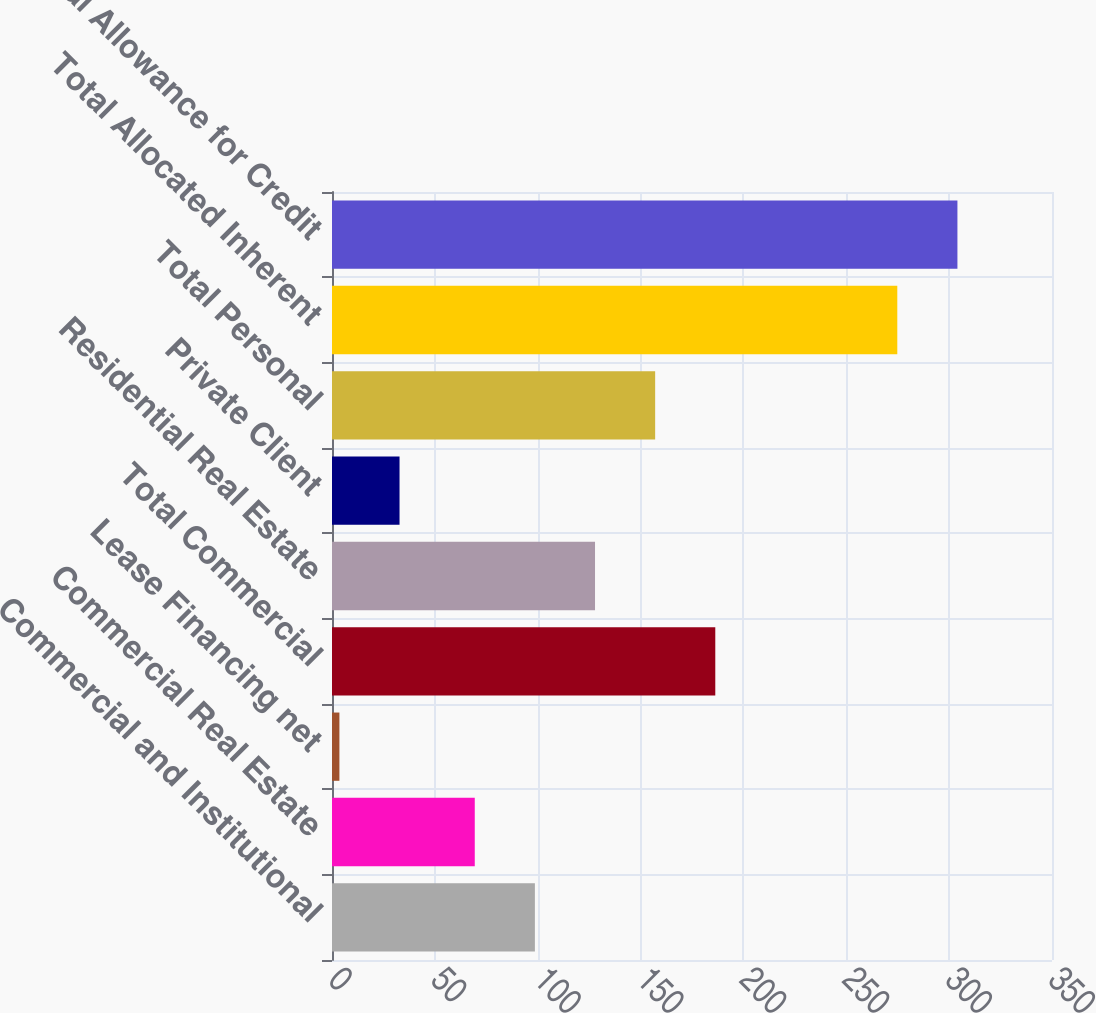Convert chart to OTSL. <chart><loc_0><loc_0><loc_500><loc_500><bar_chart><fcel>Commercial and Institutional<fcel>Commercial Real Estate<fcel>Lease Financing net<fcel>Total Commercial<fcel>Residential Real Estate<fcel>Private Client<fcel>Total Personal<fcel>Total Allocated Inherent<fcel>Total Allowance for Credit<nl><fcel>98.63<fcel>69.4<fcel>3.6<fcel>186.32<fcel>127.86<fcel>32.83<fcel>157.09<fcel>274.8<fcel>304.03<nl></chart> 